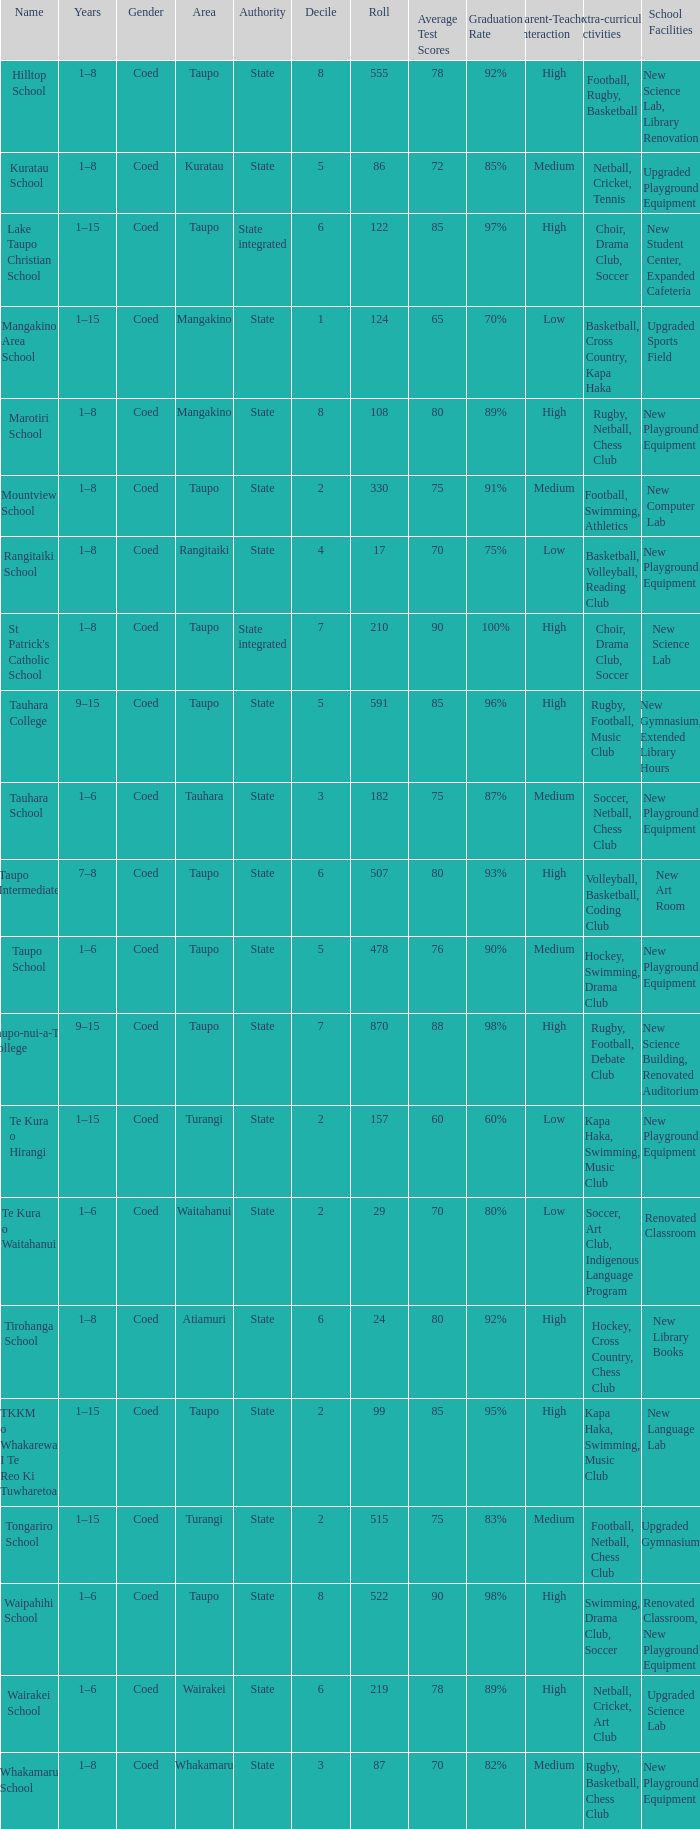What is the Whakamaru school's authority? State. 